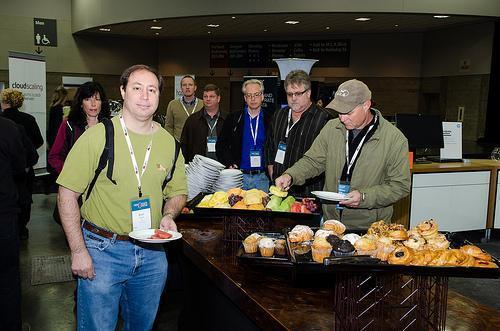How many people are standing in line?
Give a very brief answer. 7. How many people are wearing a red shirt?
Give a very brief answer. 1. 